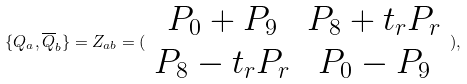Convert formula to latex. <formula><loc_0><loc_0><loc_500><loc_500>\{ Q _ { a } , \overline { Q } _ { b } \} = Z _ { a b } = ( \begin{array} { c c } P _ { 0 } + P _ { 9 } & P _ { 8 } + t _ { r } P _ { r } \\ P _ { 8 } - t _ { r } P _ { r } & P _ { 0 } - P _ { 9 } \end{array} ) ,</formula> 